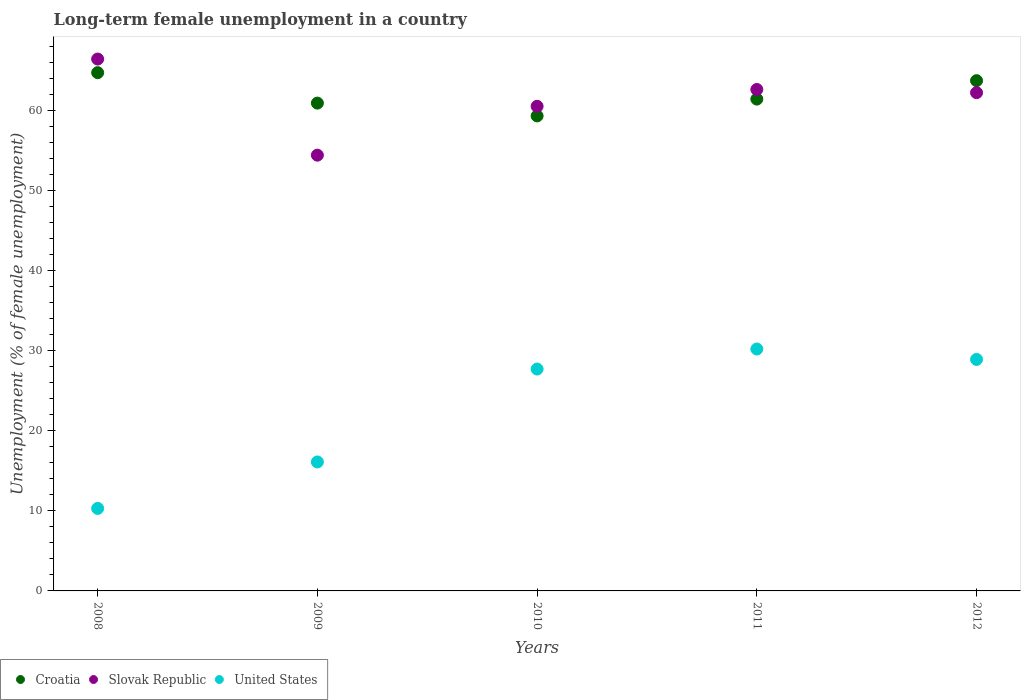What is the percentage of long-term unemployed female population in Slovak Republic in 2011?
Make the answer very short. 62.6. Across all years, what is the maximum percentage of long-term unemployed female population in Croatia?
Ensure brevity in your answer.  64.7. Across all years, what is the minimum percentage of long-term unemployed female population in Croatia?
Ensure brevity in your answer.  59.3. In which year was the percentage of long-term unemployed female population in Croatia minimum?
Your answer should be very brief. 2010. What is the total percentage of long-term unemployed female population in United States in the graph?
Your response must be concise. 113.2. What is the difference between the percentage of long-term unemployed female population in United States in 2008 and that in 2009?
Offer a very short reply. -5.8. What is the difference between the percentage of long-term unemployed female population in United States in 2011 and the percentage of long-term unemployed female population in Slovak Republic in 2012?
Offer a very short reply. -32. What is the average percentage of long-term unemployed female population in Slovak Republic per year?
Ensure brevity in your answer.  61.22. In the year 2012, what is the difference between the percentage of long-term unemployed female population in Croatia and percentage of long-term unemployed female population in Slovak Republic?
Provide a succinct answer. 1.5. What is the ratio of the percentage of long-term unemployed female population in Slovak Republic in 2008 to that in 2009?
Give a very brief answer. 1.22. Is the percentage of long-term unemployed female population in Croatia in 2008 less than that in 2009?
Provide a succinct answer. No. Is the difference between the percentage of long-term unemployed female population in Croatia in 2009 and 2011 greater than the difference between the percentage of long-term unemployed female population in Slovak Republic in 2009 and 2011?
Ensure brevity in your answer.  Yes. What is the difference between the highest and the second highest percentage of long-term unemployed female population in Croatia?
Ensure brevity in your answer.  1. What is the difference between the highest and the lowest percentage of long-term unemployed female population in Croatia?
Provide a succinct answer. 5.4. In how many years, is the percentage of long-term unemployed female population in Slovak Republic greater than the average percentage of long-term unemployed female population in Slovak Republic taken over all years?
Give a very brief answer. 3. Is it the case that in every year, the sum of the percentage of long-term unemployed female population in United States and percentage of long-term unemployed female population in Croatia  is greater than the percentage of long-term unemployed female population in Slovak Republic?
Provide a succinct answer. Yes. Is the percentage of long-term unemployed female population in Slovak Republic strictly greater than the percentage of long-term unemployed female population in United States over the years?
Make the answer very short. Yes. Is the percentage of long-term unemployed female population in United States strictly less than the percentage of long-term unemployed female population in Slovak Republic over the years?
Your response must be concise. Yes. Are the values on the major ticks of Y-axis written in scientific E-notation?
Make the answer very short. No. Does the graph contain grids?
Offer a very short reply. No. Where does the legend appear in the graph?
Offer a very short reply. Bottom left. How many legend labels are there?
Provide a succinct answer. 3. What is the title of the graph?
Your response must be concise. Long-term female unemployment in a country. Does "El Salvador" appear as one of the legend labels in the graph?
Offer a very short reply. No. What is the label or title of the Y-axis?
Ensure brevity in your answer.  Unemployment (% of female unemployment). What is the Unemployment (% of female unemployment) in Croatia in 2008?
Keep it short and to the point. 64.7. What is the Unemployment (% of female unemployment) of Slovak Republic in 2008?
Ensure brevity in your answer.  66.4. What is the Unemployment (% of female unemployment) in United States in 2008?
Your answer should be compact. 10.3. What is the Unemployment (% of female unemployment) in Croatia in 2009?
Offer a very short reply. 60.9. What is the Unemployment (% of female unemployment) in Slovak Republic in 2009?
Your answer should be very brief. 54.4. What is the Unemployment (% of female unemployment) in United States in 2009?
Ensure brevity in your answer.  16.1. What is the Unemployment (% of female unemployment) of Croatia in 2010?
Give a very brief answer. 59.3. What is the Unemployment (% of female unemployment) of Slovak Republic in 2010?
Your answer should be compact. 60.5. What is the Unemployment (% of female unemployment) of United States in 2010?
Give a very brief answer. 27.7. What is the Unemployment (% of female unemployment) in Croatia in 2011?
Your response must be concise. 61.4. What is the Unemployment (% of female unemployment) in Slovak Republic in 2011?
Your answer should be compact. 62.6. What is the Unemployment (% of female unemployment) of United States in 2011?
Keep it short and to the point. 30.2. What is the Unemployment (% of female unemployment) of Croatia in 2012?
Offer a terse response. 63.7. What is the Unemployment (% of female unemployment) in Slovak Republic in 2012?
Provide a succinct answer. 62.2. What is the Unemployment (% of female unemployment) in United States in 2012?
Give a very brief answer. 28.9. Across all years, what is the maximum Unemployment (% of female unemployment) of Croatia?
Provide a short and direct response. 64.7. Across all years, what is the maximum Unemployment (% of female unemployment) in Slovak Republic?
Ensure brevity in your answer.  66.4. Across all years, what is the maximum Unemployment (% of female unemployment) in United States?
Give a very brief answer. 30.2. Across all years, what is the minimum Unemployment (% of female unemployment) of Croatia?
Ensure brevity in your answer.  59.3. Across all years, what is the minimum Unemployment (% of female unemployment) in Slovak Republic?
Provide a short and direct response. 54.4. Across all years, what is the minimum Unemployment (% of female unemployment) of United States?
Keep it short and to the point. 10.3. What is the total Unemployment (% of female unemployment) of Croatia in the graph?
Make the answer very short. 310. What is the total Unemployment (% of female unemployment) of Slovak Republic in the graph?
Your answer should be compact. 306.1. What is the total Unemployment (% of female unemployment) of United States in the graph?
Keep it short and to the point. 113.2. What is the difference between the Unemployment (% of female unemployment) in Croatia in 2008 and that in 2009?
Your response must be concise. 3.8. What is the difference between the Unemployment (% of female unemployment) of United States in 2008 and that in 2010?
Your response must be concise. -17.4. What is the difference between the Unemployment (% of female unemployment) in Croatia in 2008 and that in 2011?
Give a very brief answer. 3.3. What is the difference between the Unemployment (% of female unemployment) of United States in 2008 and that in 2011?
Provide a short and direct response. -19.9. What is the difference between the Unemployment (% of female unemployment) in United States in 2008 and that in 2012?
Offer a terse response. -18.6. What is the difference between the Unemployment (% of female unemployment) of Slovak Republic in 2009 and that in 2010?
Provide a short and direct response. -6.1. What is the difference between the Unemployment (% of female unemployment) of United States in 2009 and that in 2010?
Offer a very short reply. -11.6. What is the difference between the Unemployment (% of female unemployment) in United States in 2009 and that in 2011?
Your response must be concise. -14.1. What is the difference between the Unemployment (% of female unemployment) in Croatia in 2010 and that in 2011?
Offer a very short reply. -2.1. What is the difference between the Unemployment (% of female unemployment) in Slovak Republic in 2010 and that in 2012?
Keep it short and to the point. -1.7. What is the difference between the Unemployment (% of female unemployment) of United States in 2010 and that in 2012?
Offer a terse response. -1.2. What is the difference between the Unemployment (% of female unemployment) of Croatia in 2011 and that in 2012?
Keep it short and to the point. -2.3. What is the difference between the Unemployment (% of female unemployment) in Croatia in 2008 and the Unemployment (% of female unemployment) in Slovak Republic in 2009?
Keep it short and to the point. 10.3. What is the difference between the Unemployment (% of female unemployment) in Croatia in 2008 and the Unemployment (% of female unemployment) in United States in 2009?
Your response must be concise. 48.6. What is the difference between the Unemployment (% of female unemployment) in Slovak Republic in 2008 and the Unemployment (% of female unemployment) in United States in 2009?
Your answer should be very brief. 50.3. What is the difference between the Unemployment (% of female unemployment) in Croatia in 2008 and the Unemployment (% of female unemployment) in Slovak Republic in 2010?
Provide a short and direct response. 4.2. What is the difference between the Unemployment (% of female unemployment) of Slovak Republic in 2008 and the Unemployment (% of female unemployment) of United States in 2010?
Make the answer very short. 38.7. What is the difference between the Unemployment (% of female unemployment) in Croatia in 2008 and the Unemployment (% of female unemployment) in United States in 2011?
Give a very brief answer. 34.5. What is the difference between the Unemployment (% of female unemployment) in Slovak Republic in 2008 and the Unemployment (% of female unemployment) in United States in 2011?
Your answer should be compact. 36.2. What is the difference between the Unemployment (% of female unemployment) in Croatia in 2008 and the Unemployment (% of female unemployment) in Slovak Republic in 2012?
Make the answer very short. 2.5. What is the difference between the Unemployment (% of female unemployment) in Croatia in 2008 and the Unemployment (% of female unemployment) in United States in 2012?
Your response must be concise. 35.8. What is the difference between the Unemployment (% of female unemployment) of Slovak Republic in 2008 and the Unemployment (% of female unemployment) of United States in 2012?
Provide a succinct answer. 37.5. What is the difference between the Unemployment (% of female unemployment) in Croatia in 2009 and the Unemployment (% of female unemployment) in Slovak Republic in 2010?
Provide a succinct answer. 0.4. What is the difference between the Unemployment (% of female unemployment) in Croatia in 2009 and the Unemployment (% of female unemployment) in United States in 2010?
Ensure brevity in your answer.  33.2. What is the difference between the Unemployment (% of female unemployment) of Slovak Republic in 2009 and the Unemployment (% of female unemployment) of United States in 2010?
Your answer should be compact. 26.7. What is the difference between the Unemployment (% of female unemployment) of Croatia in 2009 and the Unemployment (% of female unemployment) of United States in 2011?
Offer a very short reply. 30.7. What is the difference between the Unemployment (% of female unemployment) of Slovak Republic in 2009 and the Unemployment (% of female unemployment) of United States in 2011?
Keep it short and to the point. 24.2. What is the difference between the Unemployment (% of female unemployment) of Croatia in 2009 and the Unemployment (% of female unemployment) of Slovak Republic in 2012?
Offer a terse response. -1.3. What is the difference between the Unemployment (% of female unemployment) of Croatia in 2010 and the Unemployment (% of female unemployment) of United States in 2011?
Offer a very short reply. 29.1. What is the difference between the Unemployment (% of female unemployment) of Slovak Republic in 2010 and the Unemployment (% of female unemployment) of United States in 2011?
Ensure brevity in your answer.  30.3. What is the difference between the Unemployment (% of female unemployment) in Croatia in 2010 and the Unemployment (% of female unemployment) in Slovak Republic in 2012?
Ensure brevity in your answer.  -2.9. What is the difference between the Unemployment (% of female unemployment) of Croatia in 2010 and the Unemployment (% of female unemployment) of United States in 2012?
Your response must be concise. 30.4. What is the difference between the Unemployment (% of female unemployment) in Slovak Republic in 2010 and the Unemployment (% of female unemployment) in United States in 2012?
Keep it short and to the point. 31.6. What is the difference between the Unemployment (% of female unemployment) of Croatia in 2011 and the Unemployment (% of female unemployment) of United States in 2012?
Ensure brevity in your answer.  32.5. What is the difference between the Unemployment (% of female unemployment) of Slovak Republic in 2011 and the Unemployment (% of female unemployment) of United States in 2012?
Offer a terse response. 33.7. What is the average Unemployment (% of female unemployment) of Slovak Republic per year?
Offer a very short reply. 61.22. What is the average Unemployment (% of female unemployment) of United States per year?
Provide a short and direct response. 22.64. In the year 2008, what is the difference between the Unemployment (% of female unemployment) in Croatia and Unemployment (% of female unemployment) in United States?
Offer a very short reply. 54.4. In the year 2008, what is the difference between the Unemployment (% of female unemployment) in Slovak Republic and Unemployment (% of female unemployment) in United States?
Offer a terse response. 56.1. In the year 2009, what is the difference between the Unemployment (% of female unemployment) of Croatia and Unemployment (% of female unemployment) of United States?
Keep it short and to the point. 44.8. In the year 2009, what is the difference between the Unemployment (% of female unemployment) in Slovak Republic and Unemployment (% of female unemployment) in United States?
Make the answer very short. 38.3. In the year 2010, what is the difference between the Unemployment (% of female unemployment) in Croatia and Unemployment (% of female unemployment) in United States?
Your answer should be compact. 31.6. In the year 2010, what is the difference between the Unemployment (% of female unemployment) in Slovak Republic and Unemployment (% of female unemployment) in United States?
Provide a short and direct response. 32.8. In the year 2011, what is the difference between the Unemployment (% of female unemployment) of Croatia and Unemployment (% of female unemployment) of Slovak Republic?
Keep it short and to the point. -1.2. In the year 2011, what is the difference between the Unemployment (% of female unemployment) of Croatia and Unemployment (% of female unemployment) of United States?
Make the answer very short. 31.2. In the year 2011, what is the difference between the Unemployment (% of female unemployment) in Slovak Republic and Unemployment (% of female unemployment) in United States?
Provide a short and direct response. 32.4. In the year 2012, what is the difference between the Unemployment (% of female unemployment) of Croatia and Unemployment (% of female unemployment) of Slovak Republic?
Give a very brief answer. 1.5. In the year 2012, what is the difference between the Unemployment (% of female unemployment) of Croatia and Unemployment (% of female unemployment) of United States?
Make the answer very short. 34.8. In the year 2012, what is the difference between the Unemployment (% of female unemployment) of Slovak Republic and Unemployment (% of female unemployment) of United States?
Keep it short and to the point. 33.3. What is the ratio of the Unemployment (% of female unemployment) in Croatia in 2008 to that in 2009?
Give a very brief answer. 1.06. What is the ratio of the Unemployment (% of female unemployment) of Slovak Republic in 2008 to that in 2009?
Provide a short and direct response. 1.22. What is the ratio of the Unemployment (% of female unemployment) of United States in 2008 to that in 2009?
Your response must be concise. 0.64. What is the ratio of the Unemployment (% of female unemployment) of Croatia in 2008 to that in 2010?
Provide a short and direct response. 1.09. What is the ratio of the Unemployment (% of female unemployment) of Slovak Republic in 2008 to that in 2010?
Make the answer very short. 1.1. What is the ratio of the Unemployment (% of female unemployment) in United States in 2008 to that in 2010?
Ensure brevity in your answer.  0.37. What is the ratio of the Unemployment (% of female unemployment) of Croatia in 2008 to that in 2011?
Keep it short and to the point. 1.05. What is the ratio of the Unemployment (% of female unemployment) in Slovak Republic in 2008 to that in 2011?
Your answer should be compact. 1.06. What is the ratio of the Unemployment (% of female unemployment) in United States in 2008 to that in 2011?
Give a very brief answer. 0.34. What is the ratio of the Unemployment (% of female unemployment) of Croatia in 2008 to that in 2012?
Offer a very short reply. 1.02. What is the ratio of the Unemployment (% of female unemployment) of Slovak Republic in 2008 to that in 2012?
Provide a short and direct response. 1.07. What is the ratio of the Unemployment (% of female unemployment) in United States in 2008 to that in 2012?
Your answer should be compact. 0.36. What is the ratio of the Unemployment (% of female unemployment) of Slovak Republic in 2009 to that in 2010?
Ensure brevity in your answer.  0.9. What is the ratio of the Unemployment (% of female unemployment) of United States in 2009 to that in 2010?
Keep it short and to the point. 0.58. What is the ratio of the Unemployment (% of female unemployment) of Slovak Republic in 2009 to that in 2011?
Ensure brevity in your answer.  0.87. What is the ratio of the Unemployment (% of female unemployment) of United States in 2009 to that in 2011?
Offer a terse response. 0.53. What is the ratio of the Unemployment (% of female unemployment) of Croatia in 2009 to that in 2012?
Offer a terse response. 0.96. What is the ratio of the Unemployment (% of female unemployment) in Slovak Republic in 2009 to that in 2012?
Offer a terse response. 0.87. What is the ratio of the Unemployment (% of female unemployment) of United States in 2009 to that in 2012?
Ensure brevity in your answer.  0.56. What is the ratio of the Unemployment (% of female unemployment) of Croatia in 2010 to that in 2011?
Your answer should be compact. 0.97. What is the ratio of the Unemployment (% of female unemployment) in Slovak Republic in 2010 to that in 2011?
Provide a succinct answer. 0.97. What is the ratio of the Unemployment (% of female unemployment) of United States in 2010 to that in 2011?
Make the answer very short. 0.92. What is the ratio of the Unemployment (% of female unemployment) in Croatia in 2010 to that in 2012?
Provide a succinct answer. 0.93. What is the ratio of the Unemployment (% of female unemployment) in Slovak Republic in 2010 to that in 2012?
Give a very brief answer. 0.97. What is the ratio of the Unemployment (% of female unemployment) of United States in 2010 to that in 2012?
Your answer should be very brief. 0.96. What is the ratio of the Unemployment (% of female unemployment) in Croatia in 2011 to that in 2012?
Your answer should be compact. 0.96. What is the ratio of the Unemployment (% of female unemployment) in Slovak Republic in 2011 to that in 2012?
Keep it short and to the point. 1.01. What is the ratio of the Unemployment (% of female unemployment) of United States in 2011 to that in 2012?
Provide a succinct answer. 1.04. What is the difference between the highest and the second highest Unemployment (% of female unemployment) of Croatia?
Provide a short and direct response. 1. What is the difference between the highest and the second highest Unemployment (% of female unemployment) of United States?
Provide a short and direct response. 1.3. What is the difference between the highest and the lowest Unemployment (% of female unemployment) of Slovak Republic?
Offer a very short reply. 12. 